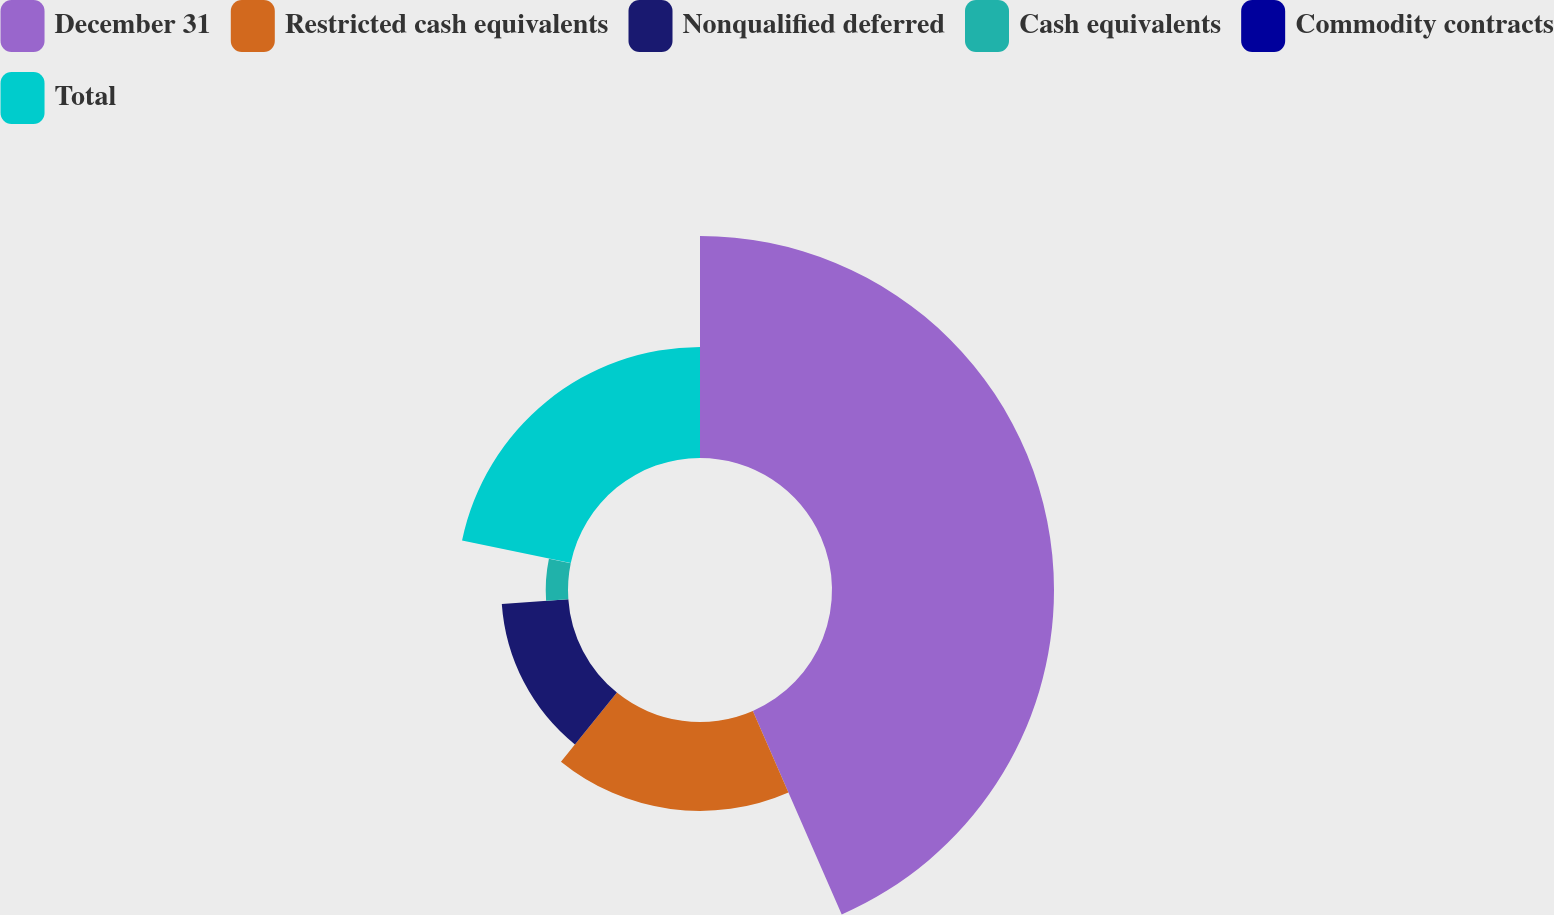Convert chart. <chart><loc_0><loc_0><loc_500><loc_500><pie_chart><fcel>December 31<fcel>Restricted cash equivalents<fcel>Nonqualified deferred<fcel>Cash equivalents<fcel>Commodity contracts<fcel>Total<nl><fcel>43.44%<fcel>17.39%<fcel>13.05%<fcel>4.36%<fcel>0.02%<fcel>21.73%<nl></chart> 